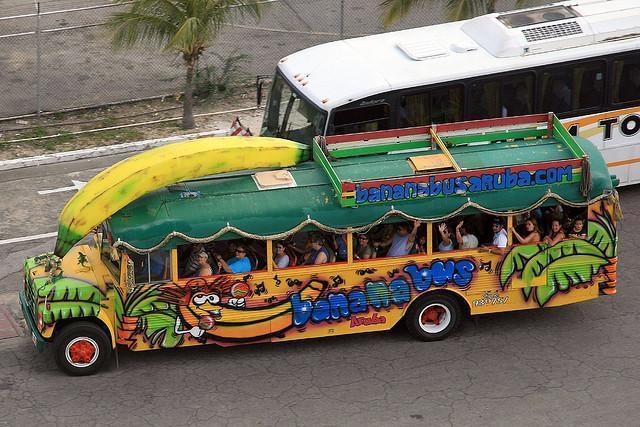How many buses are there?
Give a very brief answer. 2. How many cars are facing north in the picture?
Give a very brief answer. 0. 